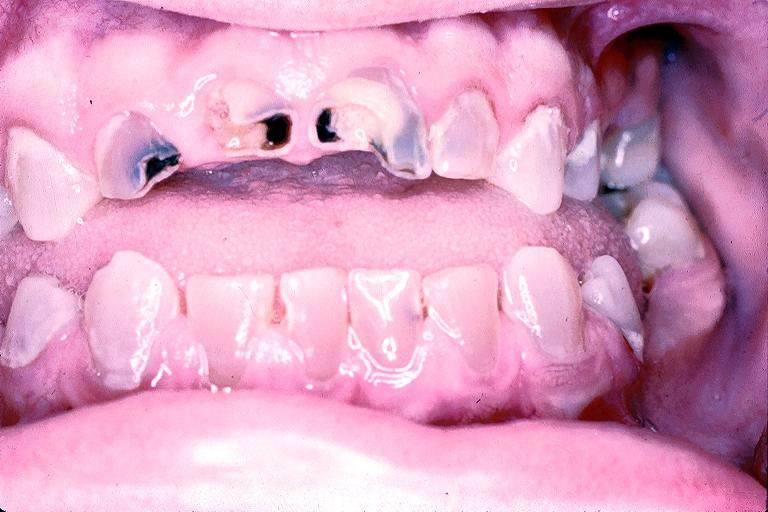does median lobe hyperplasia with marked cystitis and bladder hypertrophy ureter show dentinogenesis imperfecta?
Answer the question using a single word or phrase. No 